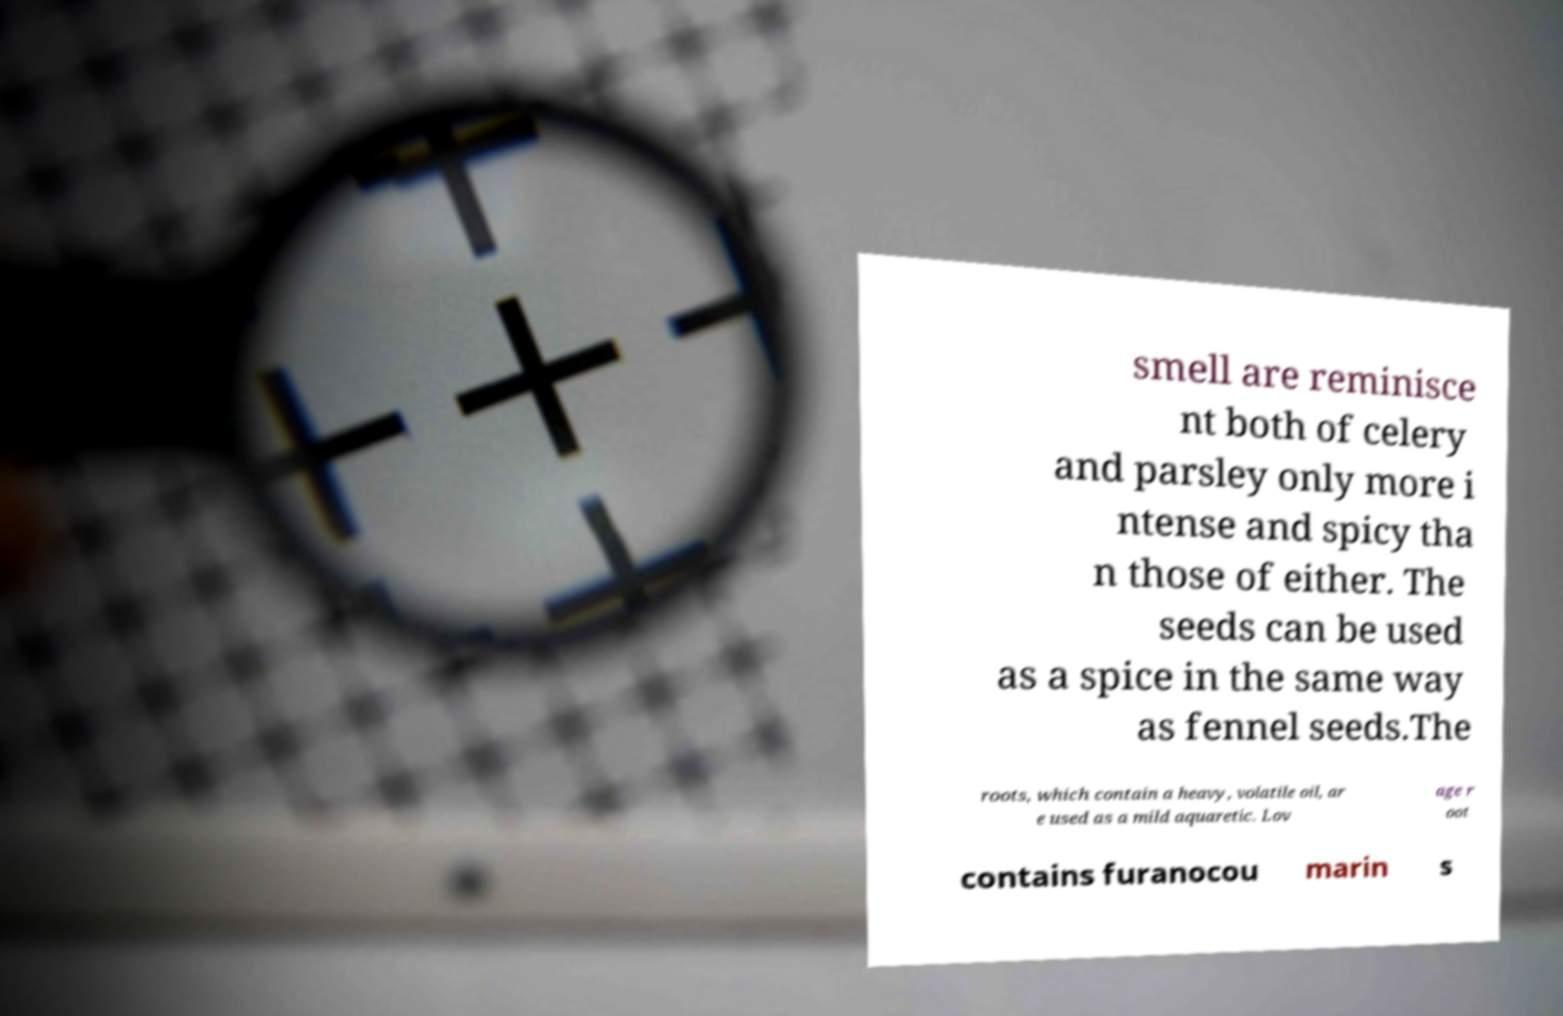There's text embedded in this image that I need extracted. Can you transcribe it verbatim? smell are reminisce nt both of celery and parsley only more i ntense and spicy tha n those of either. The seeds can be used as a spice in the same way as fennel seeds.The roots, which contain a heavy, volatile oil, ar e used as a mild aquaretic. Lov age r oot contains furanocou marin s 